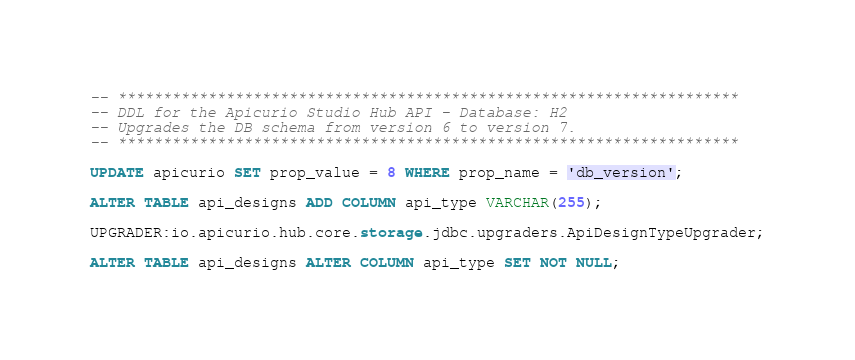<code> <loc_0><loc_0><loc_500><loc_500><_SQL_>-- *********************************************************************
-- DDL for the Apicurio Studio Hub API - Database: H2
-- Upgrades the DB schema from version 6 to version 7.
-- *********************************************************************

UPDATE apicurio SET prop_value = 8 WHERE prop_name = 'db_version';

ALTER TABLE api_designs ADD COLUMN api_type VARCHAR(255);

UPGRADER:io.apicurio.hub.core.storage.jdbc.upgraders.ApiDesignTypeUpgrader;

ALTER TABLE api_designs ALTER COLUMN api_type SET NOT NULL;
</code> 